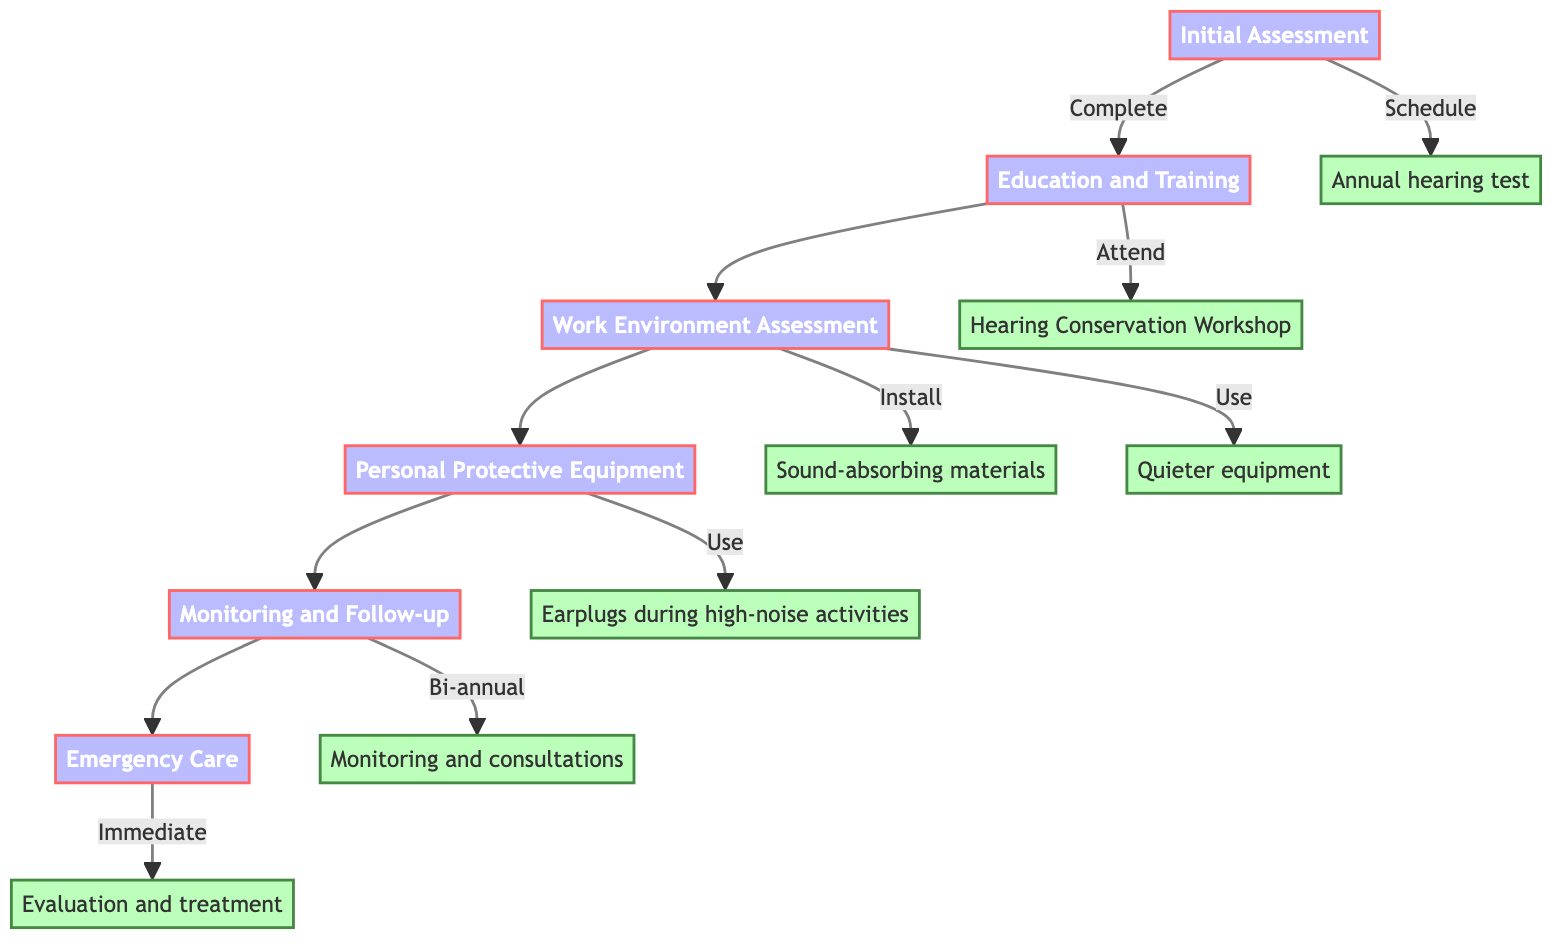What is the first step in the pathway? The diagram indicates the first step is "Initial Assessment". I identify this by looking at the top node in the flowchart that does not have any incoming connections.
Answer: Initial Assessment How many main steps are there in the pathway? To find the total number of main steps, I count each of the nodes that represent a step in the pathway, which results in six distinct steps.
Answer: 6 What follows "Work Environment Assessment" in the pathway? By examining the connections in the flowchart, I see that "Personal Protective Equipment" is directly connected to "Work Environment Assessment" as the next step.
Answer: Personal Protective Equipment What recommended action is linked with "Education and Training"? I look at the action connected to the "Education and Training" step and see that it leads to "Attend a Hearing Conservation Workshop".
Answer: Attend a Hearing Conservation Workshop How many involved parties are listed for "Monitoring and Follow-up"? The diagram shows that three parties, "Audiologist", "Occupational Health Specialist", and "College Radio DJ", are involved in the "Monitoring and Follow-up" step, thus I count these distinct parties.
Answer: 3 Which step is connected to "Immediate evaluation and treatment"? I trace the pathway from "Emergency Care" which ends in "Immediate evaluation and treatment", so this information indicates a direct connection.
Answer: Emergency Care What is the recommended action following "Emergency Care"? There does not appear to be any action that follows "Emergency Care" in the diagram as it is the last step, indicating it leads to a conclusion of the pathway.
Answer: None What is the last step in the clinical pathway? I look for the node furthest down in the diagram; "Emergency Care" is the final step as it has no outgoing connections.
Answer: Emergency Care Which involved party is common in both "Personal Protective Equipment" and "Monitoring and Follow-up"? I find the common entity by checking both steps; "Audiologist" is listed as an involved party in both.
Answer: Audiologist What action is recommended for "Work Environment Assessment"? I check the actions stemming from "Work Environment Assessment", identifying two actions: "Install sound-absorbing materials" and "Use quieter equipment".
Answer: Install sound-absorbing materials, Use quieter equipment 